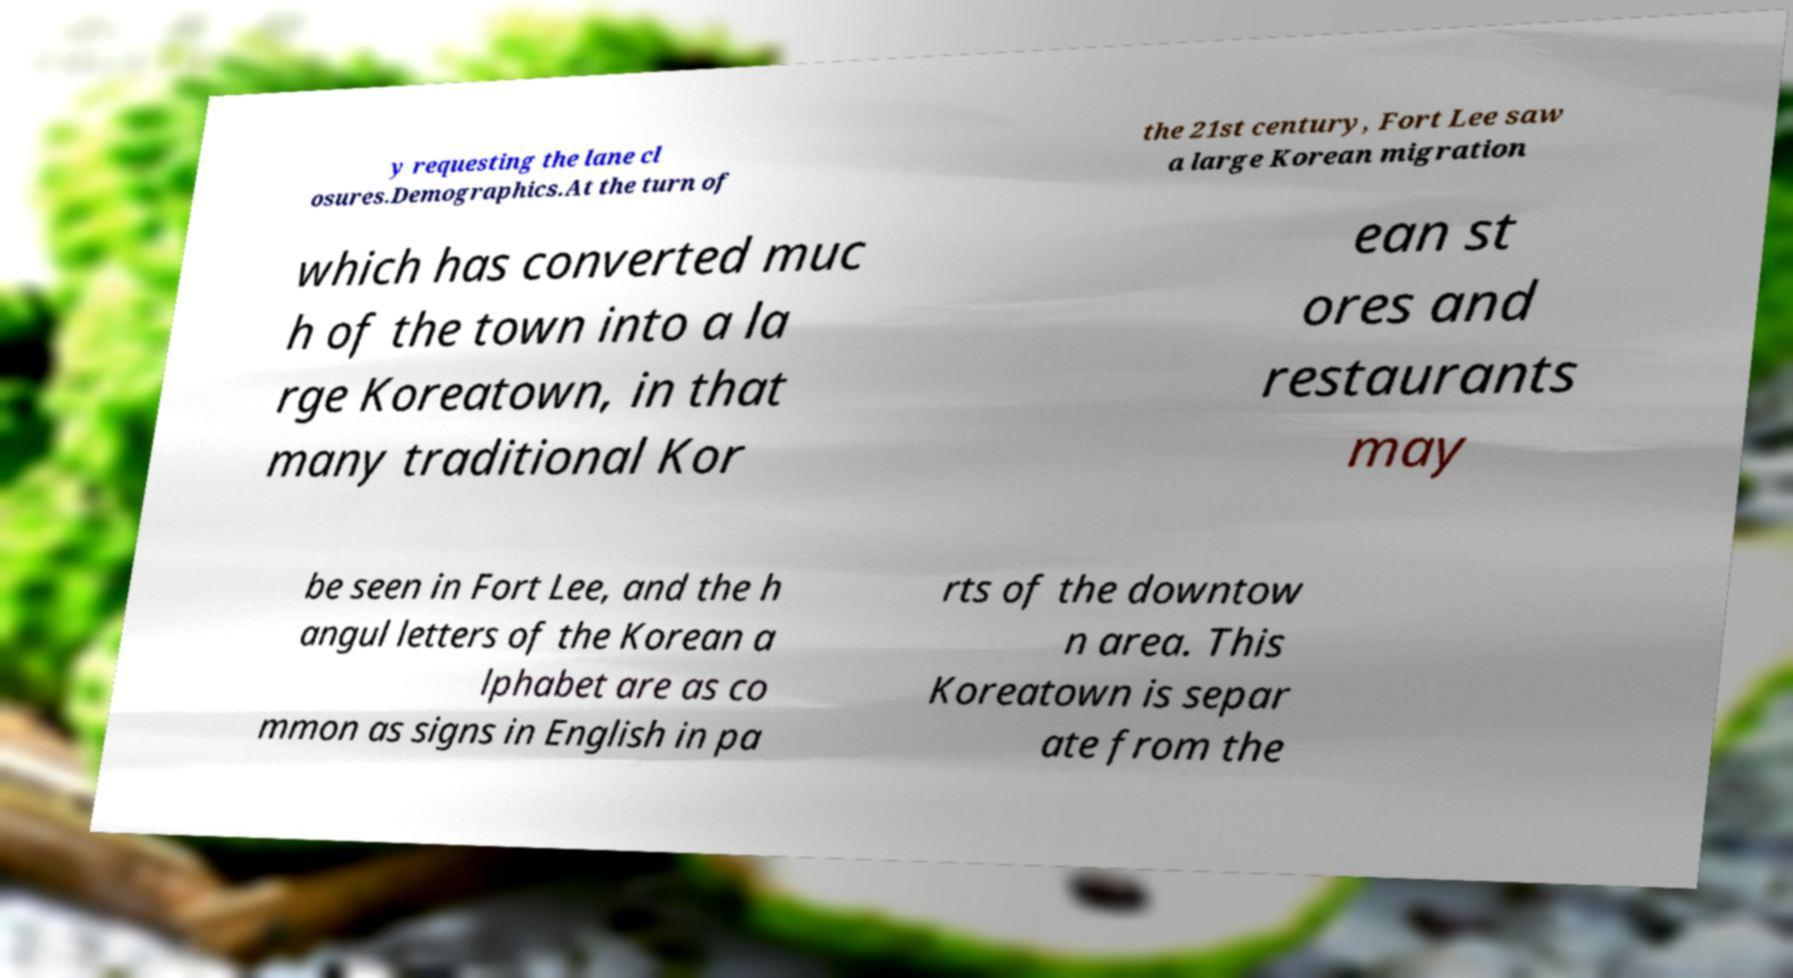What messages or text are displayed in this image? I need them in a readable, typed format. y requesting the lane cl osures.Demographics.At the turn of the 21st century, Fort Lee saw a large Korean migration which has converted muc h of the town into a la rge Koreatown, in that many traditional Kor ean st ores and restaurants may be seen in Fort Lee, and the h angul letters of the Korean a lphabet are as co mmon as signs in English in pa rts of the downtow n area. This Koreatown is separ ate from the 